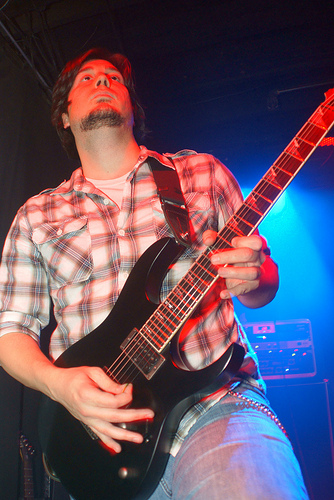<image>
Is the light in front of the guitar? No. The light is not in front of the guitar. The spatial positioning shows a different relationship between these objects. 